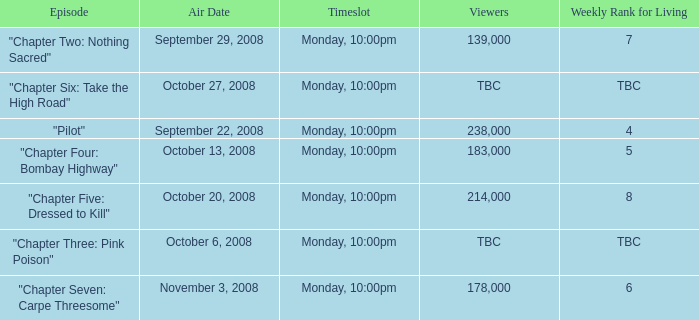What is the episode with the 183,000 viewers? "Chapter Four: Bombay Highway". 